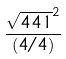Convert formula to latex. <formula><loc_0><loc_0><loc_500><loc_500>\frac { \sqrt { 4 4 1 } ^ { 2 } } { ( 4 / 4 ) }</formula> 